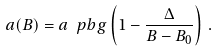<formula> <loc_0><loc_0><loc_500><loc_500>a ( B ) = a _ { \ } p { b g } \left ( 1 - \frac { \Delta } { B - B _ { 0 } } \right ) \, .</formula> 